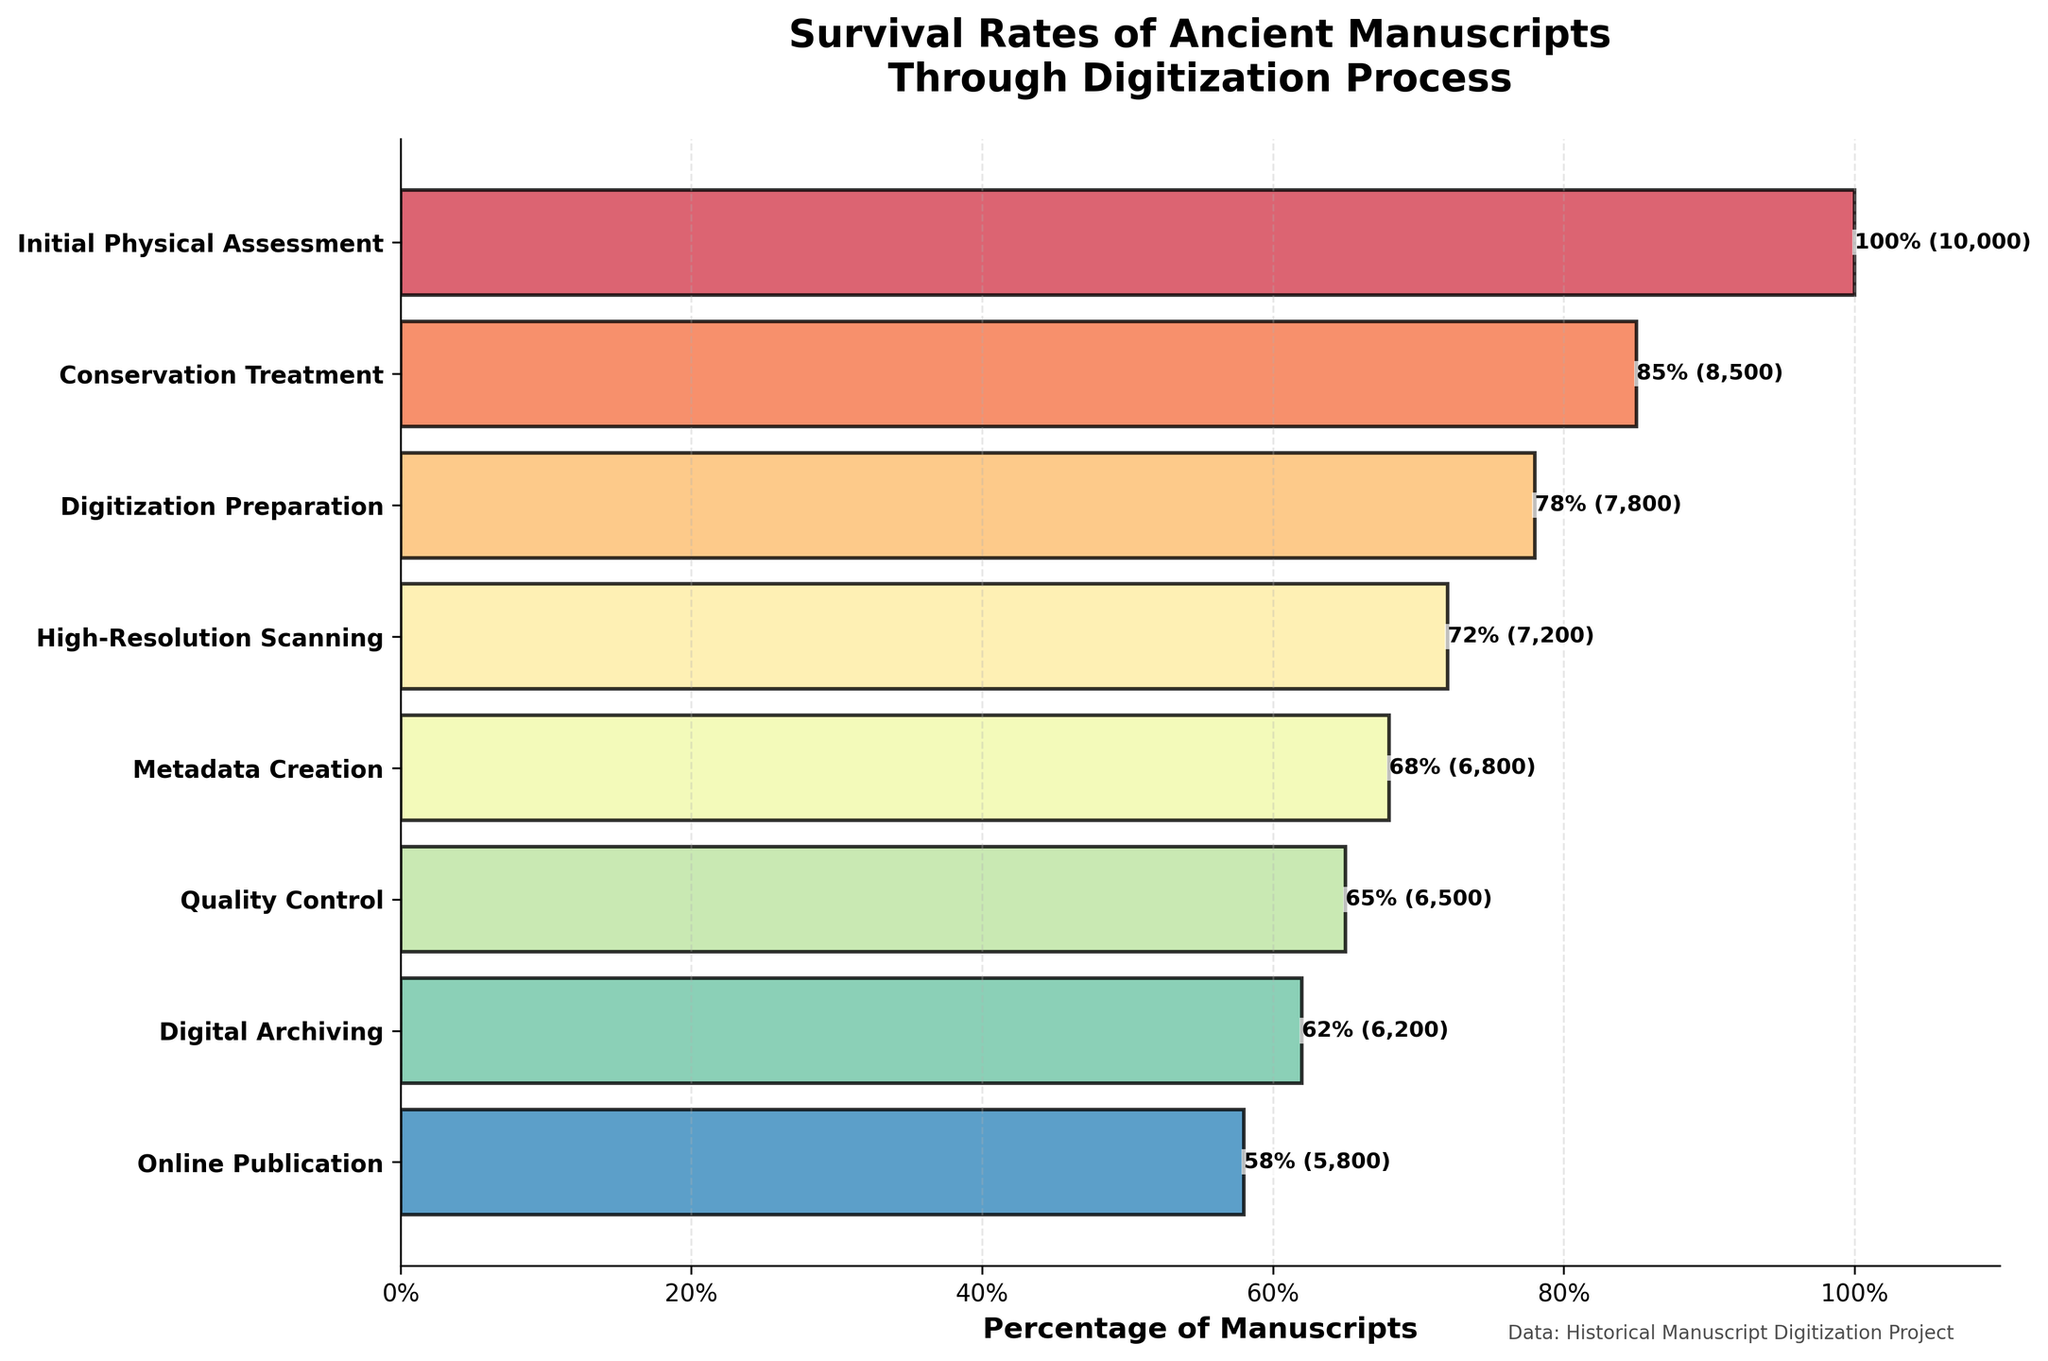What is the title of the plot? The title is shown at the top center of the plot and it reads "Survival Rates of Ancient Manuscripts Through Digitization Process".
Answer: Survival Rates of Ancient Manuscripts Through Digitization Process How many steps are included in the funnel chart? The number of steps can be counted from the y-axis labels on the plot. There are eight steps listed from top to bottom.
Answer: 8 At which step do 6800 manuscripts remain? The step associated with 6800 manuscripts can be located at the corresponding y-axis label that has this value. This step is "Metadata Creation".
Answer: Metadata Creation Compare the number of manuscripts in the initial physical assessment and the digitization preparation steps. Which step has more manuscripts? By observing the y-axis labels and the corresponding values, "Initial Physical Assessment" has 10000 manuscripts, and "Digitization Preparation" has 7800 manuscripts. The Initial Physical Assessment step has more manuscripts.
Answer: Initial Physical Assessment What percentage of manuscripts survive after the High-Resolution Scanning step? The percentage is visually indicated on the bar corresponding to the "High-Resolution Scanning" step, where it shows 72%.
Answer: 72% How many manuscripts are lost between Conservation Treatment and Quality Control? The number of manuscripts in Conservation Treatment is 8500, and for Quality Control, it is 6500. The loss is the difference: 8500 - 6500 = 2000.
Answer: 2000 Identify the step where the survival rate drops below 70%. Review the percentages annotated along the bars. The step where the percentage drops below 70% is "Metadata Creation", with 68%.
Answer: Metadata Creation Which step sees the smallest decrease in the number of manuscripts from the previous step? By comparing the differences: 
From "Initial Physical Assessment" to "Conservation Treatment": 10000 - 8500 = 1500
From "Conservation Treatment" to "Digitization Preparation": 8500 - 7800 = 700
From "Digitization Preparation" to "High-Resolution Scanning": 7800 - 7200 = 600
From "High-Resolution Scanning" to "Metadata Creation": 7200 - 6800 = 400
From "Metadata Creation" to "Quality Control": 6800 - 6500 = 300
From "Quality Control" to "Digital Archiving": 6500 - 6200 = 300
From "Digital Archiving" to "Online Publication": 6200 - 5800 = 400
The smallest decrease is 300 manuscripts, happening between "Metadata Creation" to "Quality Control" and "Quality Control" to "Digital Archiving".
Answer: 300 What is the percentage drop from the Initial Physical Assessment to Online Publication? The initial percentage is 100%, and the final percentage at Online Publication is 58%. The drop is calculated by the difference: 100% - 58% = 42%.
Answer: 42% 